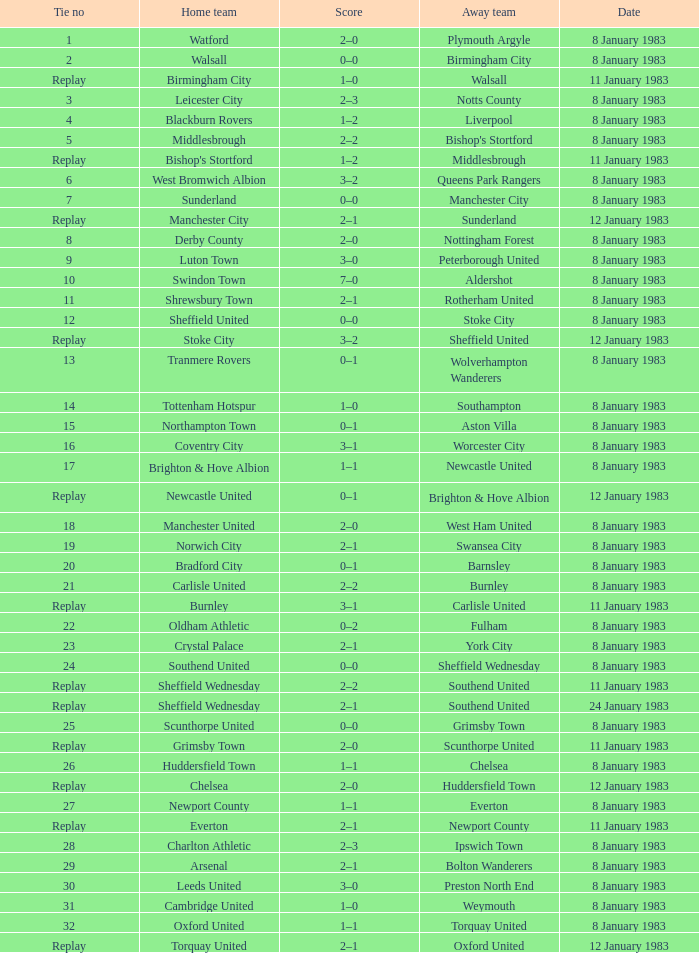What was the final score for the tie where Leeds United was the home team? 3–0. 